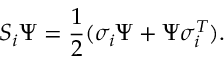<formula> <loc_0><loc_0><loc_500><loc_500>S _ { i } \Psi = \frac { 1 } { 2 } ( \sigma _ { i } \Psi + \Psi \sigma _ { i } ^ { T } ) .</formula> 